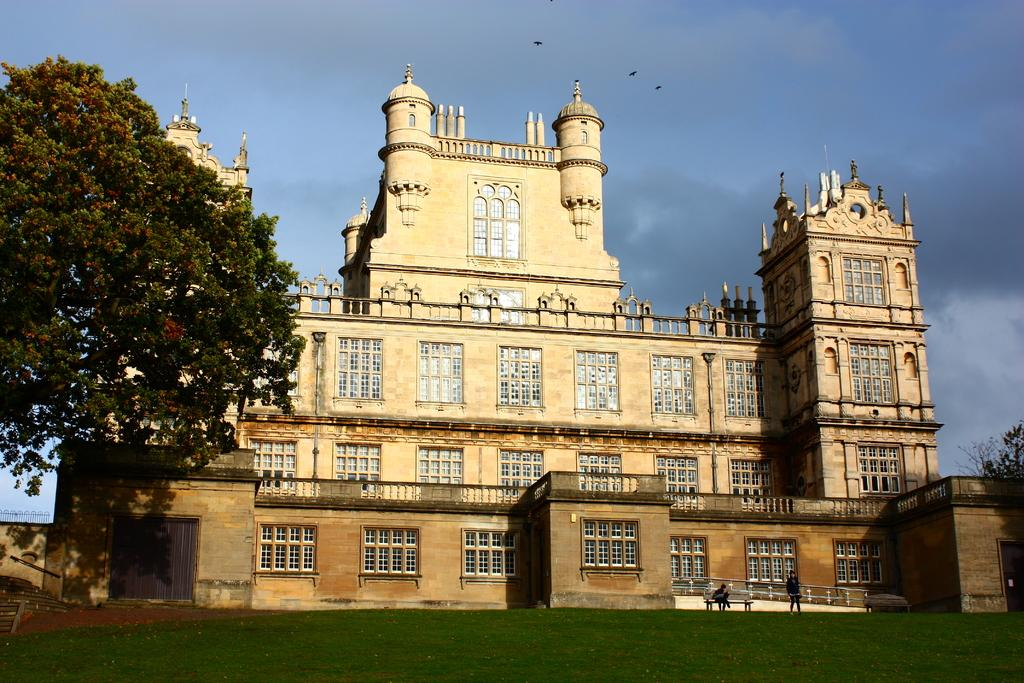What type of structure is visible in the image? There is a building in the image. Where is the tree located in the image? The tree is on the left side of the image. What color is the grass in the image? The grass is green in the image. What color is the sky in the image? The sky is blue in the image. Can you see any worms crawling on the tree in the image? There are no worms visible in the image; it only shows a tree, a building, green grass, and a blue sky. 